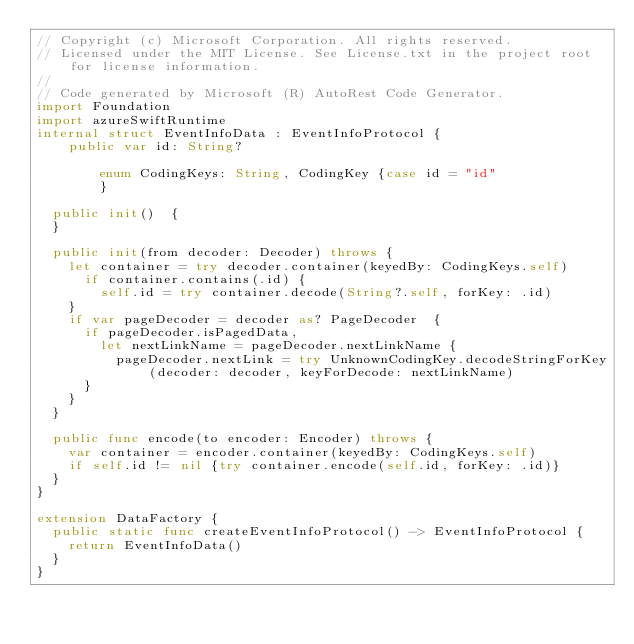<code> <loc_0><loc_0><loc_500><loc_500><_Swift_>// Copyright (c) Microsoft Corporation. All rights reserved.
// Licensed under the MIT License. See License.txt in the project root for license information.
//
// Code generated by Microsoft (R) AutoRest Code Generator.
import Foundation
import azureSwiftRuntime
internal struct EventInfoData : EventInfoProtocol {
    public var id: String?

        enum CodingKeys: String, CodingKey {case id = "id"
        }

  public init()  {
  }

  public init(from decoder: Decoder) throws {
    let container = try decoder.container(keyedBy: CodingKeys.self)
      if container.contains(.id) {
        self.id = try container.decode(String?.self, forKey: .id)
    }
    if var pageDecoder = decoder as? PageDecoder  {
      if pageDecoder.isPagedData,
        let nextLinkName = pageDecoder.nextLinkName {
          pageDecoder.nextLink = try UnknownCodingKey.decodeStringForKey(decoder: decoder, keyForDecode: nextLinkName)
      }
    }
  }

  public func encode(to encoder: Encoder) throws {
    var container = encoder.container(keyedBy: CodingKeys.self)
    if self.id != nil {try container.encode(self.id, forKey: .id)}
  }
}

extension DataFactory {
  public static func createEventInfoProtocol() -> EventInfoProtocol {
    return EventInfoData()
  }
}
</code> 